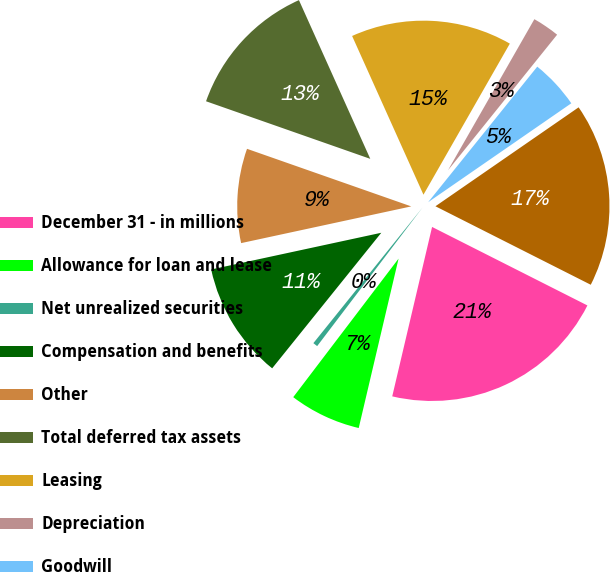Convert chart. <chart><loc_0><loc_0><loc_500><loc_500><pie_chart><fcel>December 31 - in millions<fcel>Allowance for loan and lease<fcel>Net unrealized securities<fcel>Compensation and benefits<fcel>Other<fcel>Total deferred tax assets<fcel>Leasing<fcel>Depreciation<fcel>Goodwill<fcel>BlackRock basis difference<nl><fcel>21.23%<fcel>6.67%<fcel>0.44%<fcel>10.83%<fcel>8.75%<fcel>12.91%<fcel>14.99%<fcel>2.52%<fcel>4.59%<fcel>17.07%<nl></chart> 